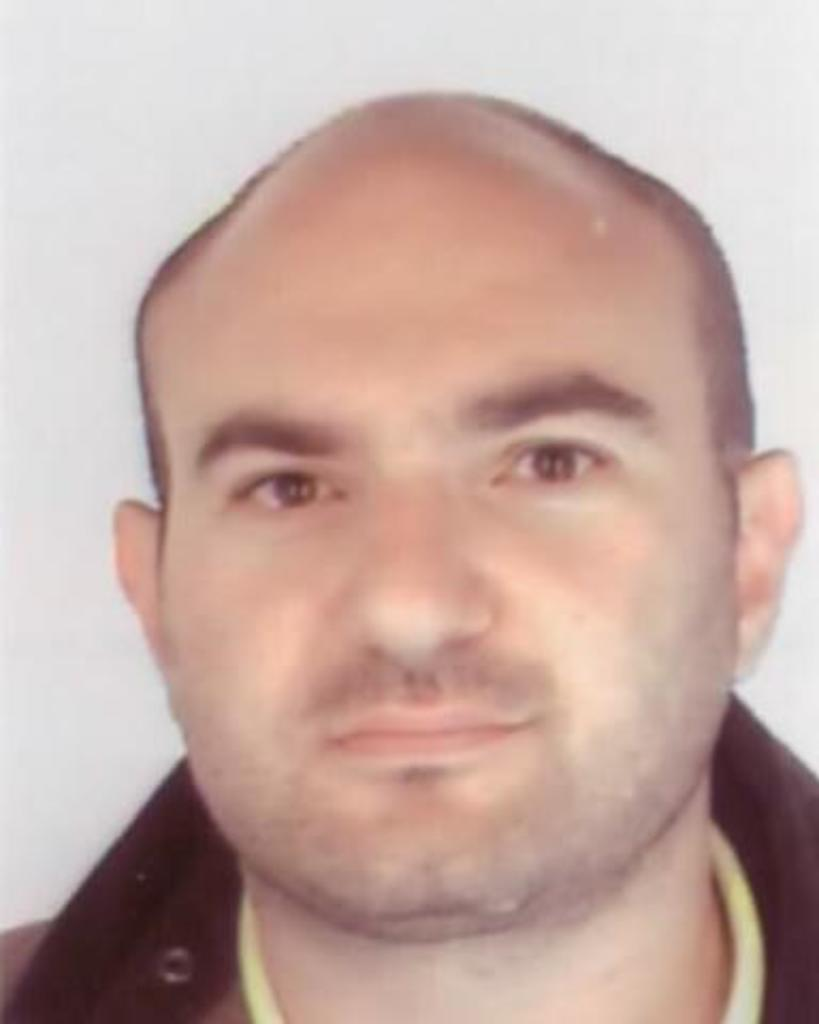What is the main subject of the image? There is a face of a person in the image. How many feet can be seen on the person's face in the image? There are no feet visible on the person's face in the image, as it is a face and not a full body. What type of bear is present on the person's face in the image? There is no bear present on the person's face in the image. What type of roof is visible on the person's face in the image? There is no roof present on the person's face in the image, as it is a face and not a building. 